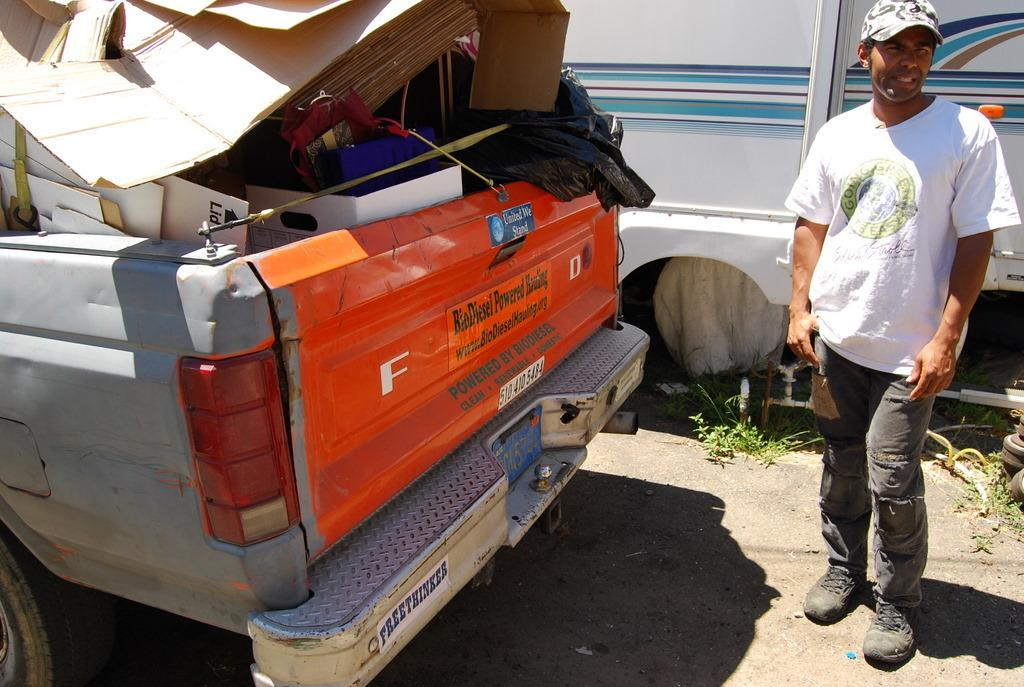What is the person doing in the image? The person is standing on the right side of the image. Where is the person standing? The person is standing on the road. What can be seen on the left side of the image? There is a truck on the left side of the image. What is in the truck? The truck has scrap in it. What is visible in the background of the image? There is a wall in the background of the image. What type of cake is being served at the condition of the road in the image? There is no cake present in the image, and the condition of the road is not related to serving cake. 